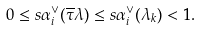<formula> <loc_0><loc_0><loc_500><loc_500>0 \leq s \alpha _ { i } ^ { \vee } ( \overline { \tau } \lambda ) \leq s \alpha _ { i } ^ { \vee } ( \lambda _ { k } ) < 1 .</formula> 